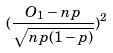Convert formula to latex. <formula><loc_0><loc_0><loc_500><loc_500>( \frac { O _ { 1 } - n p } { \sqrt { n p ( 1 - p ) } } ) ^ { 2 }</formula> 